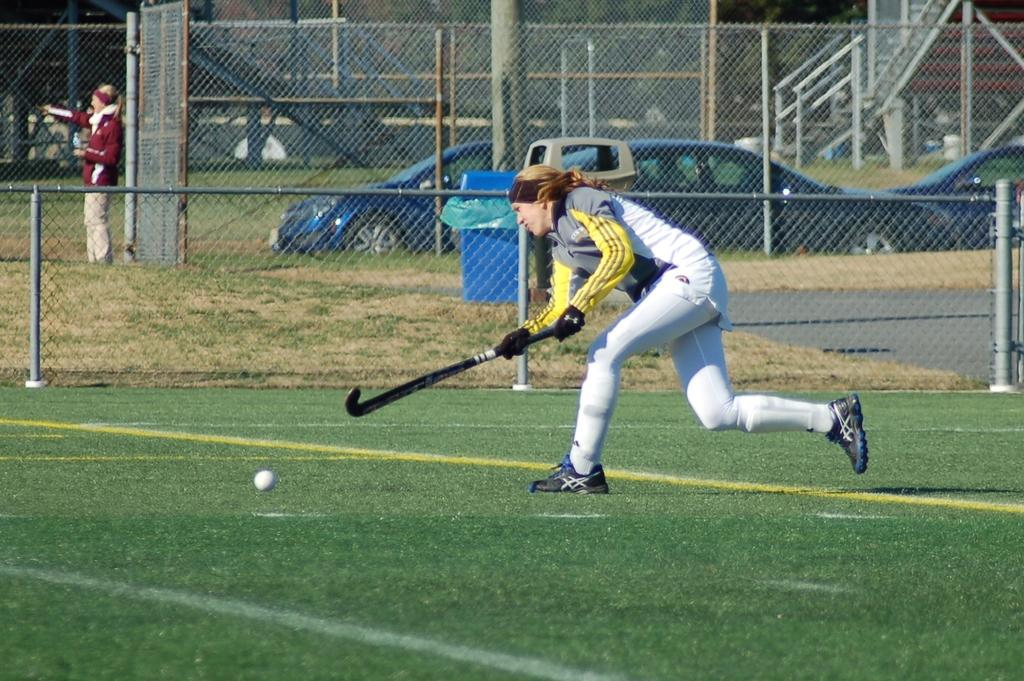What is the lady in the image doing? The lady is playing on the ground with a hockey stick. What is located behind the lady? There is a net fence behind her. Is there anyone else in the image? Yes, there is another lady standing nearby. What can be seen in the background of the image? Cars are parked in the background. What type of pleasure can be seen in the image? There is no specific pleasure depicted in the image; it shows a lady playing with a hockey stick and other elements. What kind of pot is visible in the image? There is no pot present in the image. 